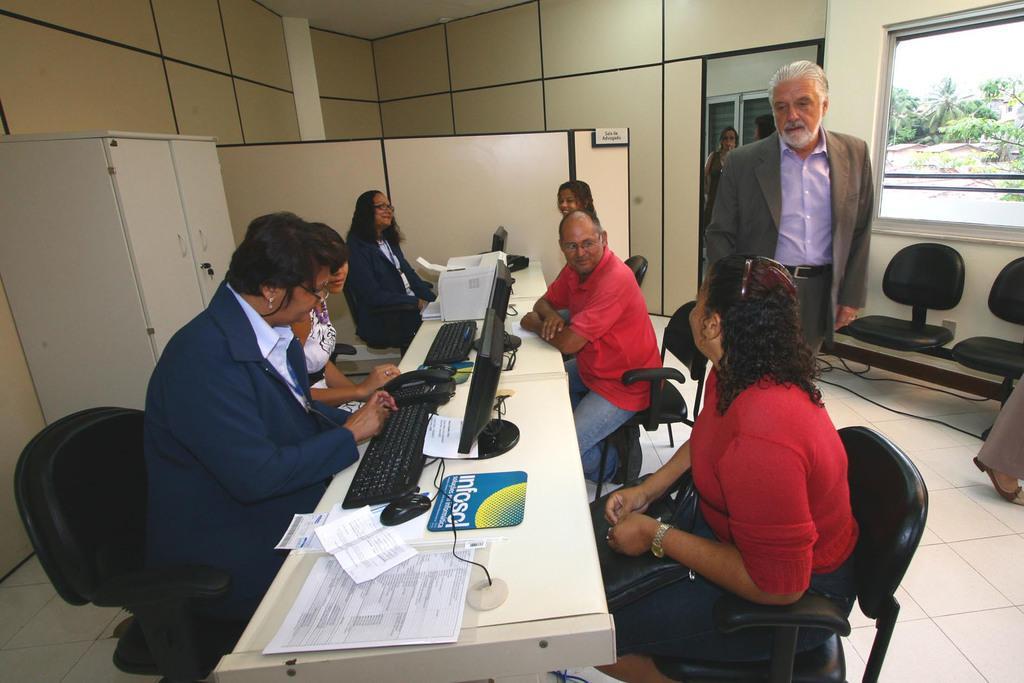In one or two sentences, can you explain what this image depicts? There is a table inside a room of an organization, a group of people were sitting around the table, on the left side there is a cabinet. A person is standing on the right side and behind him there is a window and there are two chairs in front of the window, there are many trees behind the window. 